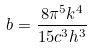Convert formula to latex. <formula><loc_0><loc_0><loc_500><loc_500>b = \frac { 8 \pi ^ { 5 } k ^ { 4 } } { 1 5 c ^ { 3 } h ^ { 3 } }</formula> 